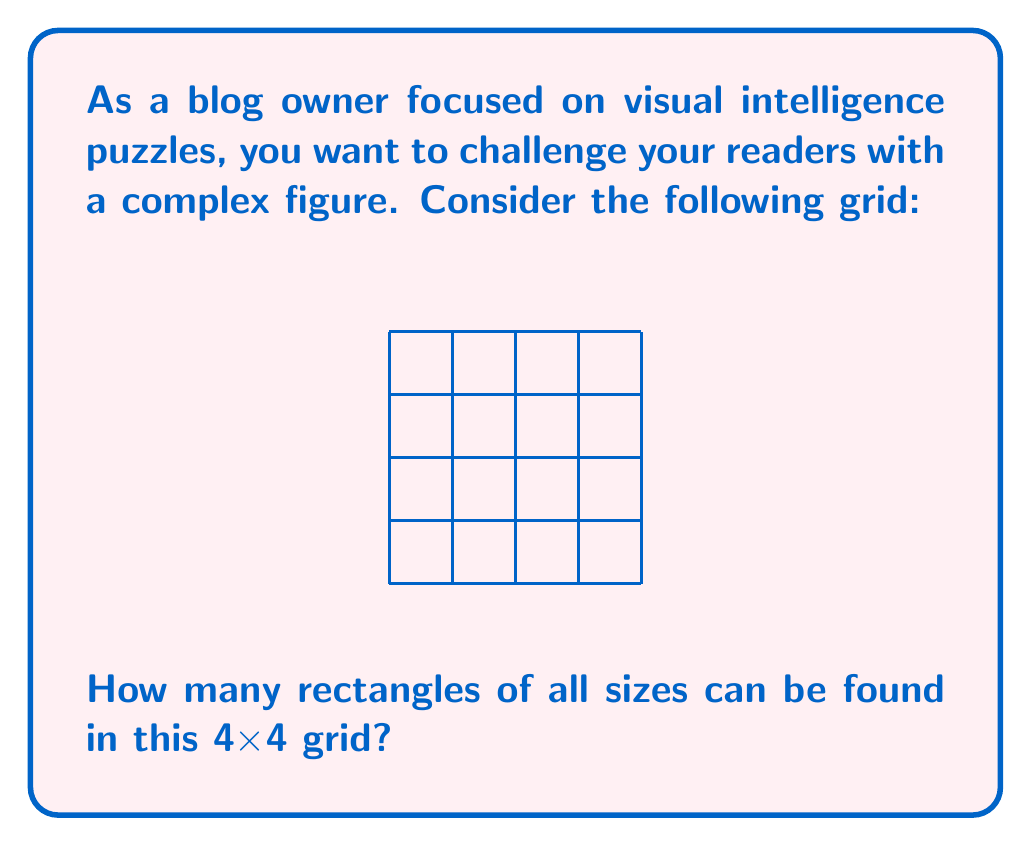Provide a solution to this math problem. Let's approach this step-by-step:

1) First, we need to understand that rectangles can be of different sizes, from 1x1 to 4x4.

2) Let's count the rectangles by their dimensions:

   a) 1x1 rectangles: There are 16 of these (4 * 4 = 16)
   
   b) 1x2 rectangles: There are 12 vertical (3 * 4 = 12) and 12 horizontal (4 * 3 = 12), totaling 24
   
   c) 1x3 rectangles: There are 8 vertical (2 * 4 = 8) and 8 horizontal (4 * 2 = 8), totaling 16
   
   d) 1x4 rectangles: There are 4 vertical and 4 horizontal, totaling 8
   
   e) 2x2 rectangles: There are 9 (3 * 3 = 9)
   
   f) 2x3 rectangles: There are 6 vertical (2 * 3 = 6) and 6 horizontal (3 * 2 = 6), totaling 12
   
   g) 2x4 rectangles: There are 3 vertical and 3 horizontal, totaling 6
   
   h) 3x3 rectangles: There are 4 (2 * 2 = 4)
   
   i) 3x4 rectangles: There are 2 vertical and 2 horizontal, totaling 4
   
   j) 4x4 rectangle: There is 1

3) Now, we sum up all these rectangles:

   $$16 + 24 + 16 + 8 + 9 + 12 + 6 + 4 + 4 + 1 = 100$$

Therefore, there are 100 rectangles in total in this 4x4 grid.
Answer: 100 